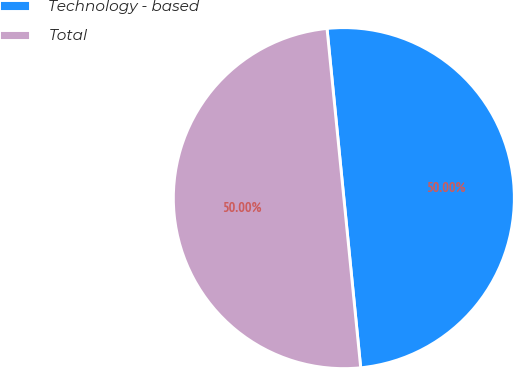<chart> <loc_0><loc_0><loc_500><loc_500><pie_chart><fcel>Technology - based<fcel>Total<nl><fcel>50.0%<fcel>50.0%<nl></chart> 